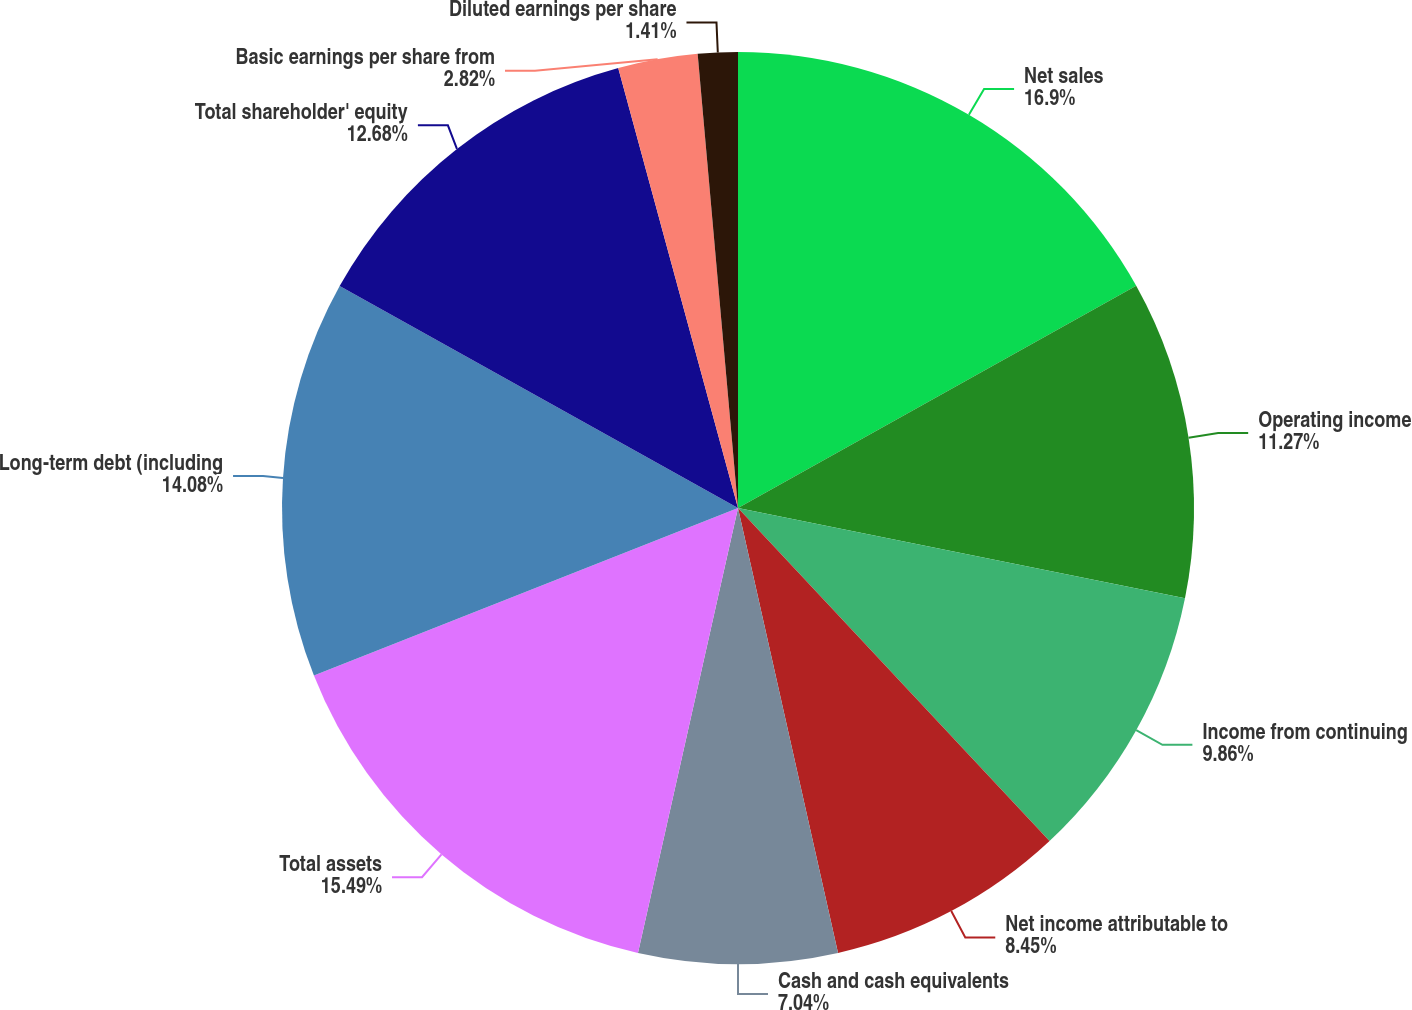Convert chart to OTSL. <chart><loc_0><loc_0><loc_500><loc_500><pie_chart><fcel>Net sales<fcel>Operating income<fcel>Income from continuing<fcel>Net income attributable to<fcel>Cash and cash equivalents<fcel>Total assets<fcel>Long-term debt (including<fcel>Total shareholder' equity<fcel>Basic earnings per share from<fcel>Diluted earnings per share<nl><fcel>16.9%<fcel>11.27%<fcel>9.86%<fcel>8.45%<fcel>7.04%<fcel>15.49%<fcel>14.08%<fcel>12.68%<fcel>2.82%<fcel>1.41%<nl></chart> 